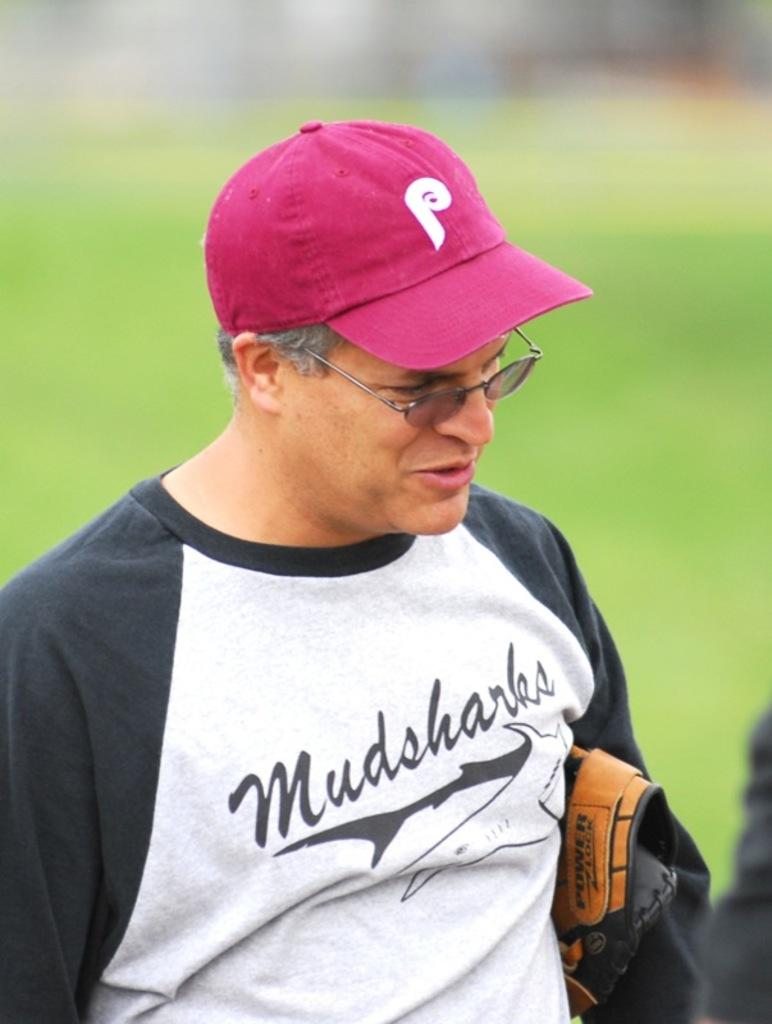<image>
Offer a succinct explanation of the picture presented. A man wearing a Mudsharks baseball tee-shirt is clutching his glove under his arm. 